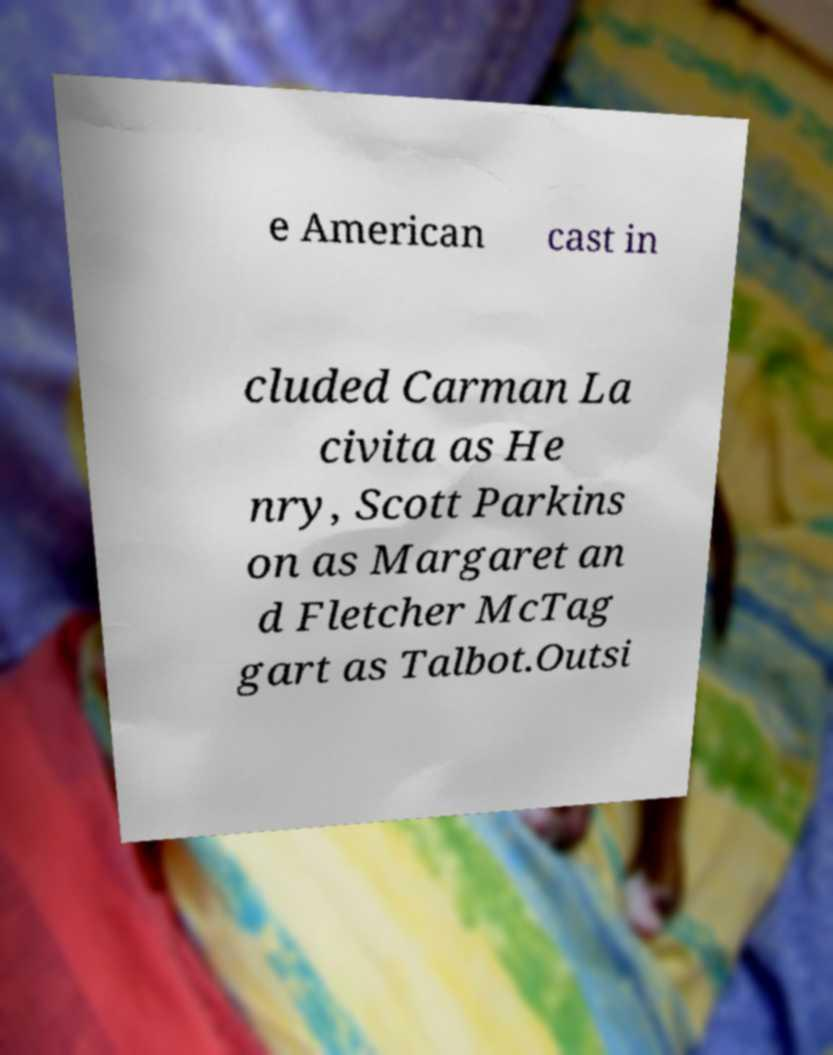I need the written content from this picture converted into text. Can you do that? e American cast in cluded Carman La civita as He nry, Scott Parkins on as Margaret an d Fletcher McTag gart as Talbot.Outsi 